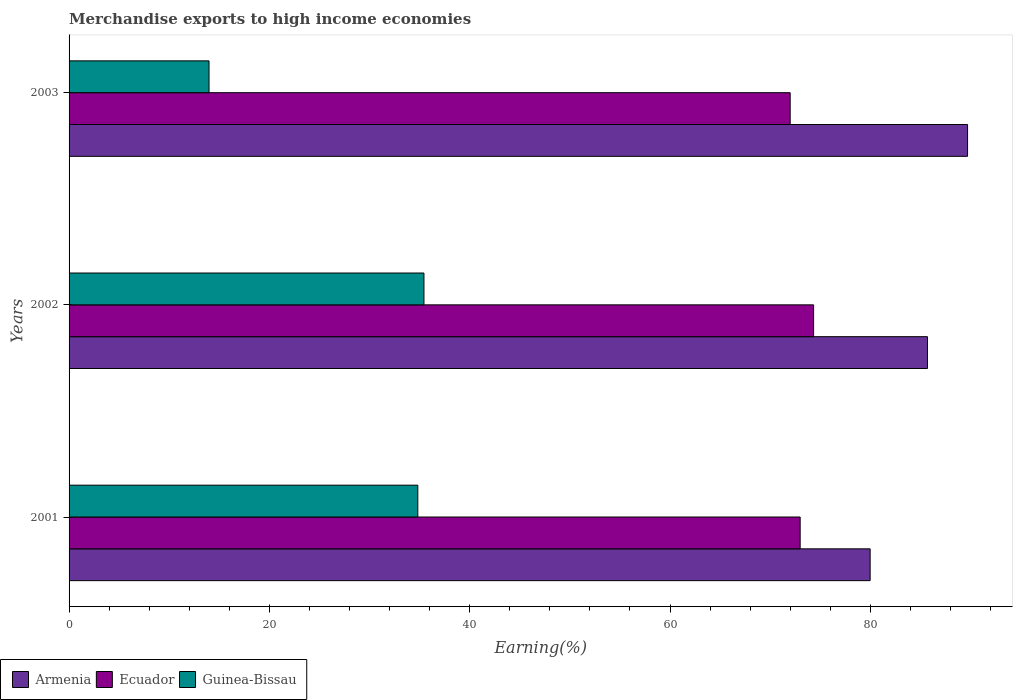How many groups of bars are there?
Keep it short and to the point. 3. How many bars are there on the 1st tick from the top?
Provide a short and direct response. 3. What is the label of the 3rd group of bars from the top?
Offer a terse response. 2001. What is the percentage of amount earned from merchandise exports in Ecuador in 2001?
Keep it short and to the point. 72.99. Across all years, what is the maximum percentage of amount earned from merchandise exports in Guinea-Bissau?
Make the answer very short. 35.43. Across all years, what is the minimum percentage of amount earned from merchandise exports in Guinea-Bissau?
Provide a short and direct response. 13.97. In which year was the percentage of amount earned from merchandise exports in Armenia maximum?
Give a very brief answer. 2003. In which year was the percentage of amount earned from merchandise exports in Guinea-Bissau minimum?
Make the answer very short. 2003. What is the total percentage of amount earned from merchandise exports in Armenia in the graph?
Your answer should be compact. 255.38. What is the difference between the percentage of amount earned from merchandise exports in Armenia in 2001 and that in 2002?
Your answer should be compact. -5.73. What is the difference between the percentage of amount earned from merchandise exports in Ecuador in 2001 and the percentage of amount earned from merchandise exports in Guinea-Bissau in 2003?
Provide a succinct answer. 59.02. What is the average percentage of amount earned from merchandise exports in Ecuador per year?
Offer a terse response. 73.11. In the year 2001, what is the difference between the percentage of amount earned from merchandise exports in Armenia and percentage of amount earned from merchandise exports in Ecuador?
Your answer should be compact. 6.99. In how many years, is the percentage of amount earned from merchandise exports in Armenia greater than 68 %?
Make the answer very short. 3. What is the ratio of the percentage of amount earned from merchandise exports in Armenia in 2002 to that in 2003?
Give a very brief answer. 0.96. Is the percentage of amount earned from merchandise exports in Guinea-Bissau in 2001 less than that in 2003?
Your answer should be compact. No. Is the difference between the percentage of amount earned from merchandise exports in Armenia in 2001 and 2002 greater than the difference between the percentage of amount earned from merchandise exports in Ecuador in 2001 and 2002?
Offer a very short reply. No. What is the difference between the highest and the second highest percentage of amount earned from merchandise exports in Armenia?
Provide a short and direct response. 4. What is the difference between the highest and the lowest percentage of amount earned from merchandise exports in Guinea-Bissau?
Your response must be concise. 21.46. Is the sum of the percentage of amount earned from merchandise exports in Guinea-Bissau in 2001 and 2002 greater than the maximum percentage of amount earned from merchandise exports in Armenia across all years?
Your answer should be very brief. No. What does the 1st bar from the top in 2002 represents?
Ensure brevity in your answer.  Guinea-Bissau. What does the 3rd bar from the bottom in 2001 represents?
Your response must be concise. Guinea-Bissau. Is it the case that in every year, the sum of the percentage of amount earned from merchandise exports in Ecuador and percentage of amount earned from merchandise exports in Armenia is greater than the percentage of amount earned from merchandise exports in Guinea-Bissau?
Your answer should be compact. Yes. Are all the bars in the graph horizontal?
Keep it short and to the point. Yes. How many years are there in the graph?
Your answer should be compact. 3. Where does the legend appear in the graph?
Your answer should be very brief. Bottom left. What is the title of the graph?
Keep it short and to the point. Merchandise exports to high income economies. What is the label or title of the X-axis?
Ensure brevity in your answer.  Earning(%). What is the label or title of the Y-axis?
Offer a terse response. Years. What is the Earning(%) in Armenia in 2001?
Your answer should be compact. 79.98. What is the Earning(%) of Ecuador in 2001?
Your answer should be very brief. 72.99. What is the Earning(%) of Guinea-Bissau in 2001?
Offer a very short reply. 34.82. What is the Earning(%) of Armenia in 2002?
Your response must be concise. 85.7. What is the Earning(%) of Ecuador in 2002?
Ensure brevity in your answer.  74.33. What is the Earning(%) in Guinea-Bissau in 2002?
Your answer should be very brief. 35.43. What is the Earning(%) of Armenia in 2003?
Give a very brief answer. 89.7. What is the Earning(%) of Ecuador in 2003?
Offer a very short reply. 71.99. What is the Earning(%) of Guinea-Bissau in 2003?
Offer a terse response. 13.97. Across all years, what is the maximum Earning(%) in Armenia?
Offer a terse response. 89.7. Across all years, what is the maximum Earning(%) of Ecuador?
Ensure brevity in your answer.  74.33. Across all years, what is the maximum Earning(%) of Guinea-Bissau?
Your answer should be very brief. 35.43. Across all years, what is the minimum Earning(%) in Armenia?
Offer a very short reply. 79.98. Across all years, what is the minimum Earning(%) in Ecuador?
Keep it short and to the point. 71.99. Across all years, what is the minimum Earning(%) in Guinea-Bissau?
Your answer should be compact. 13.97. What is the total Earning(%) of Armenia in the graph?
Offer a very short reply. 255.38. What is the total Earning(%) of Ecuador in the graph?
Provide a succinct answer. 219.32. What is the total Earning(%) in Guinea-Bissau in the graph?
Give a very brief answer. 84.22. What is the difference between the Earning(%) of Armenia in 2001 and that in 2002?
Ensure brevity in your answer.  -5.73. What is the difference between the Earning(%) of Ecuador in 2001 and that in 2002?
Your answer should be very brief. -1.34. What is the difference between the Earning(%) of Guinea-Bissau in 2001 and that in 2002?
Keep it short and to the point. -0.61. What is the difference between the Earning(%) in Armenia in 2001 and that in 2003?
Your response must be concise. -9.73. What is the difference between the Earning(%) in Guinea-Bissau in 2001 and that in 2003?
Offer a terse response. 20.84. What is the difference between the Earning(%) of Armenia in 2002 and that in 2003?
Offer a terse response. -4. What is the difference between the Earning(%) of Ecuador in 2002 and that in 2003?
Offer a terse response. 2.34. What is the difference between the Earning(%) of Guinea-Bissau in 2002 and that in 2003?
Your answer should be very brief. 21.46. What is the difference between the Earning(%) in Armenia in 2001 and the Earning(%) in Ecuador in 2002?
Give a very brief answer. 5.64. What is the difference between the Earning(%) of Armenia in 2001 and the Earning(%) of Guinea-Bissau in 2002?
Offer a very short reply. 44.55. What is the difference between the Earning(%) in Ecuador in 2001 and the Earning(%) in Guinea-Bissau in 2002?
Your answer should be very brief. 37.56. What is the difference between the Earning(%) of Armenia in 2001 and the Earning(%) of Ecuador in 2003?
Offer a terse response. 7.98. What is the difference between the Earning(%) in Armenia in 2001 and the Earning(%) in Guinea-Bissau in 2003?
Give a very brief answer. 66. What is the difference between the Earning(%) in Ecuador in 2001 and the Earning(%) in Guinea-Bissau in 2003?
Give a very brief answer. 59.02. What is the difference between the Earning(%) of Armenia in 2002 and the Earning(%) of Ecuador in 2003?
Your answer should be compact. 13.71. What is the difference between the Earning(%) in Armenia in 2002 and the Earning(%) in Guinea-Bissau in 2003?
Keep it short and to the point. 71.73. What is the difference between the Earning(%) in Ecuador in 2002 and the Earning(%) in Guinea-Bissau in 2003?
Offer a terse response. 60.36. What is the average Earning(%) in Armenia per year?
Provide a short and direct response. 85.13. What is the average Earning(%) of Ecuador per year?
Give a very brief answer. 73.11. What is the average Earning(%) of Guinea-Bissau per year?
Make the answer very short. 28.07. In the year 2001, what is the difference between the Earning(%) of Armenia and Earning(%) of Ecuador?
Your answer should be very brief. 6.99. In the year 2001, what is the difference between the Earning(%) of Armenia and Earning(%) of Guinea-Bissau?
Give a very brief answer. 45.16. In the year 2001, what is the difference between the Earning(%) in Ecuador and Earning(%) in Guinea-Bissau?
Your response must be concise. 38.17. In the year 2002, what is the difference between the Earning(%) in Armenia and Earning(%) in Ecuador?
Your response must be concise. 11.37. In the year 2002, what is the difference between the Earning(%) in Armenia and Earning(%) in Guinea-Bissau?
Keep it short and to the point. 50.27. In the year 2002, what is the difference between the Earning(%) of Ecuador and Earning(%) of Guinea-Bissau?
Your response must be concise. 38.9. In the year 2003, what is the difference between the Earning(%) of Armenia and Earning(%) of Ecuador?
Ensure brevity in your answer.  17.71. In the year 2003, what is the difference between the Earning(%) of Armenia and Earning(%) of Guinea-Bissau?
Provide a short and direct response. 75.73. In the year 2003, what is the difference between the Earning(%) in Ecuador and Earning(%) in Guinea-Bissau?
Give a very brief answer. 58.02. What is the ratio of the Earning(%) in Armenia in 2001 to that in 2002?
Provide a succinct answer. 0.93. What is the ratio of the Earning(%) of Ecuador in 2001 to that in 2002?
Your response must be concise. 0.98. What is the ratio of the Earning(%) in Guinea-Bissau in 2001 to that in 2002?
Your answer should be compact. 0.98. What is the ratio of the Earning(%) of Armenia in 2001 to that in 2003?
Your response must be concise. 0.89. What is the ratio of the Earning(%) of Ecuador in 2001 to that in 2003?
Give a very brief answer. 1.01. What is the ratio of the Earning(%) in Guinea-Bissau in 2001 to that in 2003?
Keep it short and to the point. 2.49. What is the ratio of the Earning(%) of Armenia in 2002 to that in 2003?
Offer a terse response. 0.96. What is the ratio of the Earning(%) in Ecuador in 2002 to that in 2003?
Your answer should be compact. 1.03. What is the ratio of the Earning(%) in Guinea-Bissau in 2002 to that in 2003?
Make the answer very short. 2.54. What is the difference between the highest and the second highest Earning(%) of Armenia?
Ensure brevity in your answer.  4. What is the difference between the highest and the second highest Earning(%) in Ecuador?
Provide a short and direct response. 1.34. What is the difference between the highest and the second highest Earning(%) in Guinea-Bissau?
Give a very brief answer. 0.61. What is the difference between the highest and the lowest Earning(%) in Armenia?
Offer a terse response. 9.73. What is the difference between the highest and the lowest Earning(%) in Ecuador?
Provide a succinct answer. 2.34. What is the difference between the highest and the lowest Earning(%) in Guinea-Bissau?
Make the answer very short. 21.46. 